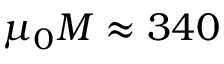<formula> <loc_0><loc_0><loc_500><loc_500>\mu _ { 0 } M \approx 3 4 0</formula> 